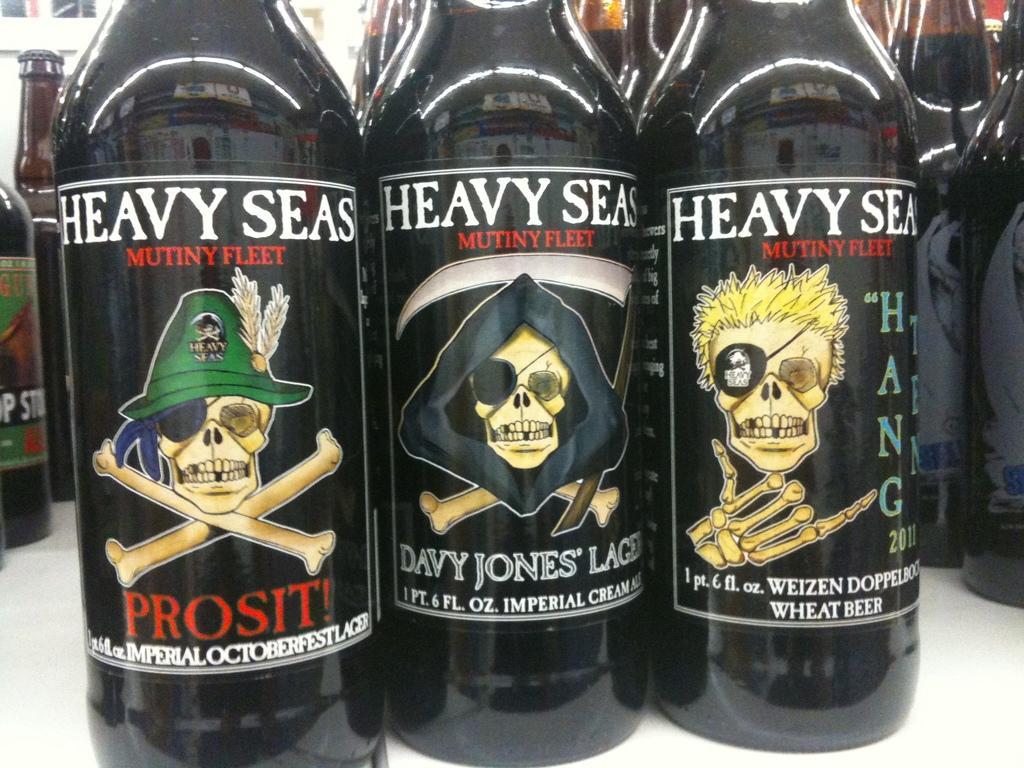Please provide a concise description of this image. These are the bottles with labels on it. 